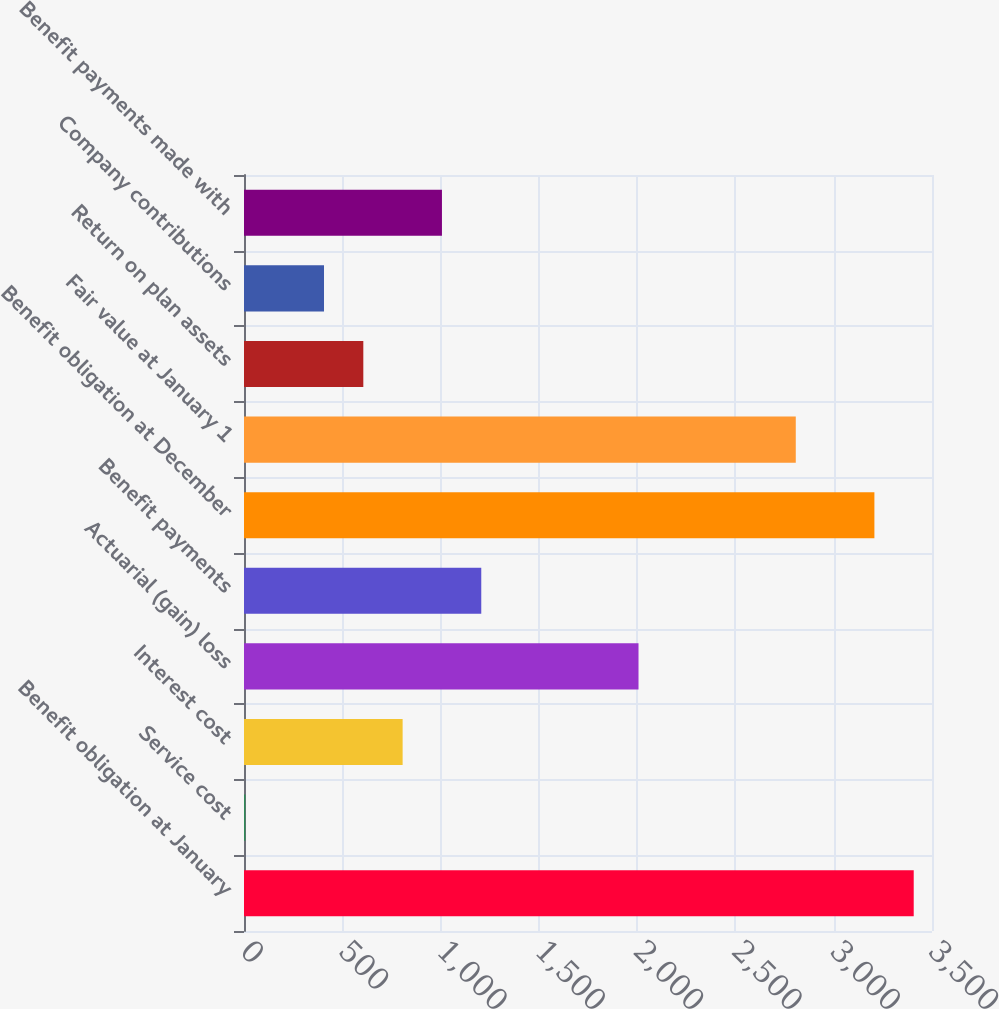Convert chart to OTSL. <chart><loc_0><loc_0><loc_500><loc_500><bar_chart><fcel>Benefit obligation at January<fcel>Service cost<fcel>Interest cost<fcel>Actuarial (gain) loss<fcel>Benefit payments<fcel>Benefit obligation at December<fcel>Fair value at January 1<fcel>Return on plan assets<fcel>Company contributions<fcel>Benefit payments made with<nl><fcel>3407<fcel>7<fcel>807<fcel>2007<fcel>1207<fcel>3207<fcel>2807<fcel>607<fcel>407<fcel>1007<nl></chart> 